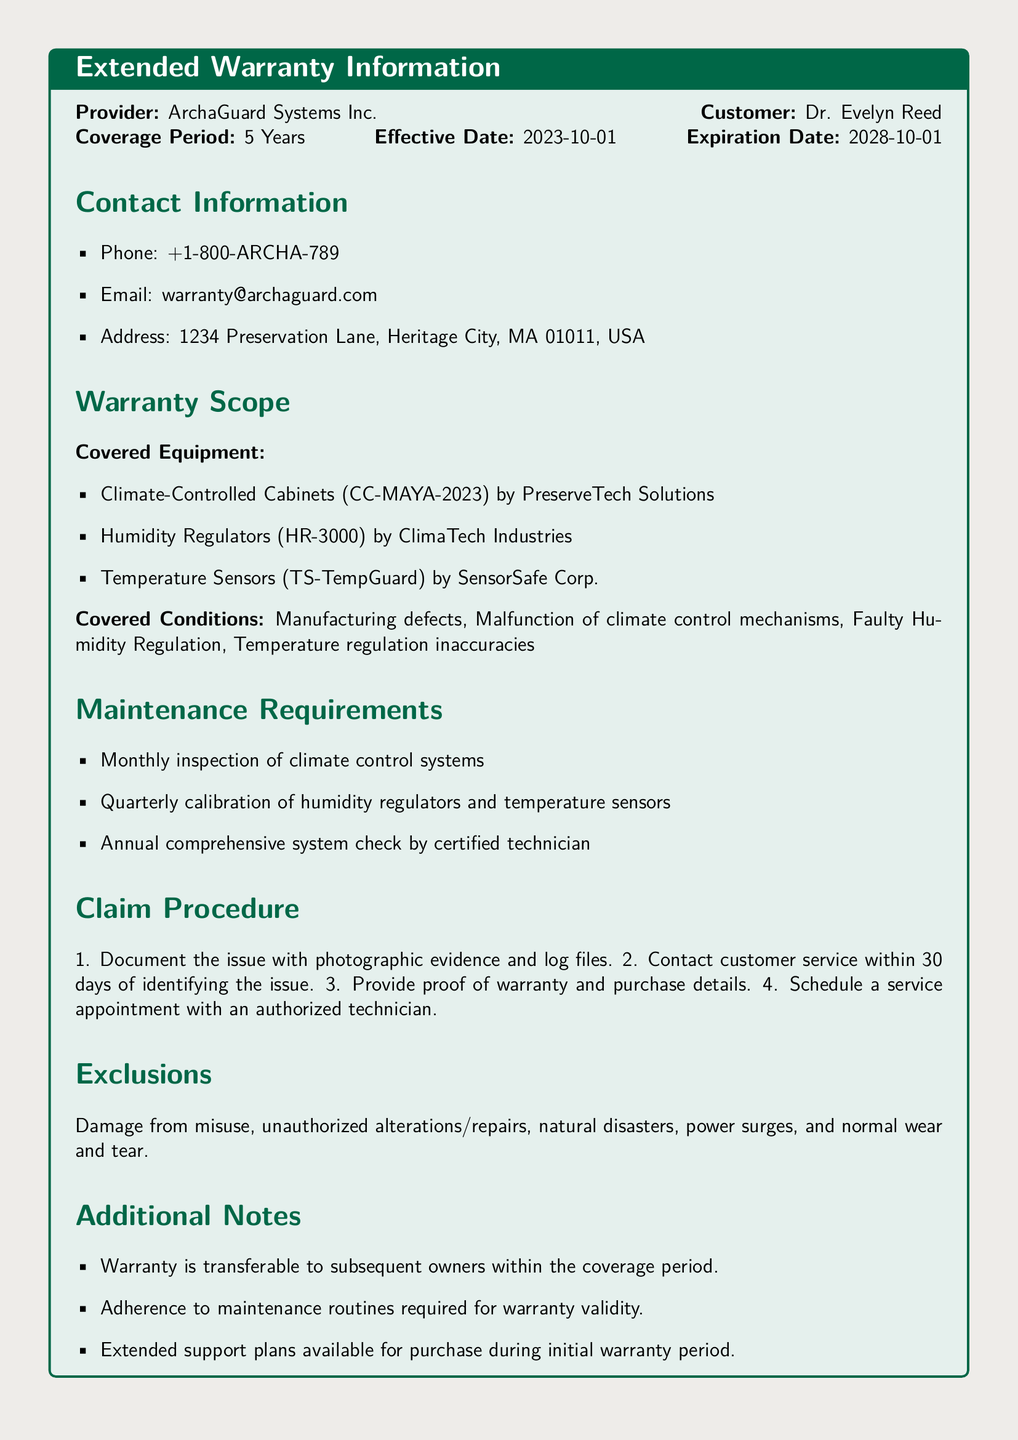What is the name of the warranty provider? The warranty provider is mentioned in the document under the provider section.
Answer: ArchaGuard Systems Inc What is the coverage period of the warranty? The coverage period is stated directly under the Coverage Period section.
Answer: 5 Years When does the warranty expire? The expiration date is indicated in the document as part of the warranty details.
Answer: 2028-10-01 Which equipment is covered by the warranty? The document lists the covered equipment in the Warranty Scope section.
Answer: Climate-Controlled Cabinets, Humidity Regulators, Temperature Sensors What is the first step in the claim procedure? The first step for filing a claim is explained in the Claim Procedure section of the document.
Answer: Document the issue with photographic evidence and log files How often should the climate control systems be inspected? The maintenance requirements specify the frequency of inspections directly.
Answer: Monthly What types of damage are excluded from the warranty? Exclusions are listed under a specific section in the document detailing what is not covered.
Answer: Misuse, unauthorized alterations, natural disasters, power surges, normal wear and tear Is the warranty transferable? The document includes information about whether the warranty can be transferred to new owners in the Additional Notes section.
Answer: Yes What is required for warranty validity? The document explicitly states a condition for maintaining warranty validity.
Answer: Adherence to maintenance routines 